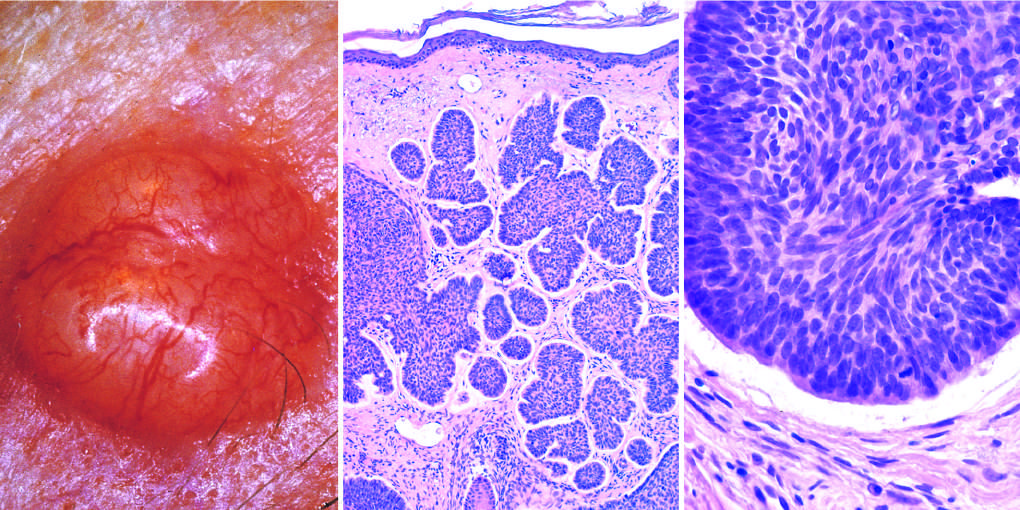s acute contusions a highly characteristic artifact of sectioning?
Answer the question using a single word or phrase. No 